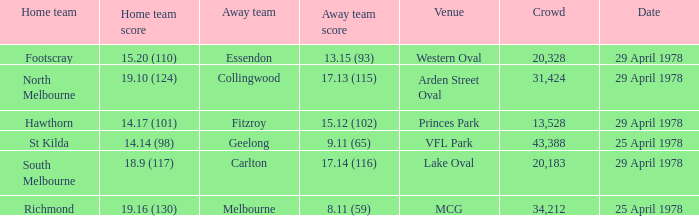In what venue was the hosted away team Essendon? Western Oval. 